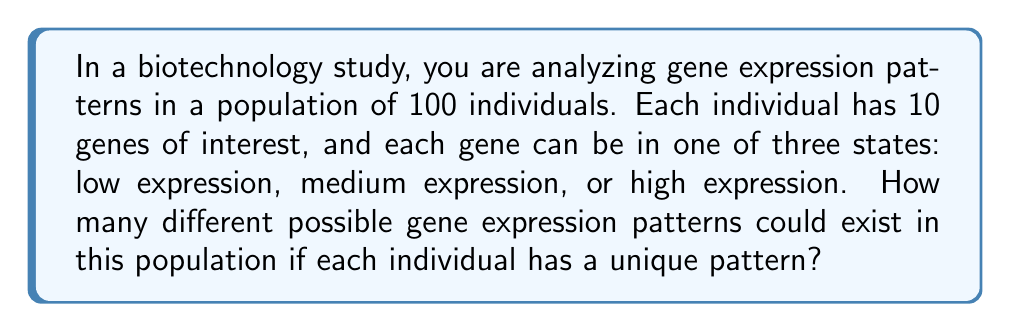Teach me how to tackle this problem. Let's approach this step-by-step:

1. First, we need to determine how many possible gene expression patterns exist for a single individual:
   - Each individual has 10 genes
   - Each gene can be in one of 3 states (low, medium, high)
   - This is a case of independent choices for each gene

2. The number of possible patterns for one individual is:
   $3^{10}$ (3 choices for each of the 10 genes)

3. Now, we need to consider the entire population:
   - There are 100 individuals
   - Each individual must have a unique pattern

4. This scenario is a permutation problem. We are selecting 100 unique patterns from the total number of possible patterns.

5. The number of ways to select 100 unique patterns from $3^{10}$ possible patterns is given by the permutation formula:

   $$P(3^{10}, 100) = \frac{3^{10}!}{(3^{10} - 100)!}$$

6. Let's calculate:
   $3^{10} = 59,049$

7. So our final calculation is:
   $$\frac{59,049!}{(59,049 - 100)!} = \frac{59,049!}{58,949!}$$

8. This number is extremely large and would typically be left in this form or calculated using specialized software or approximation methods.
Answer: $\frac{59,049!}{58,949!}$ 